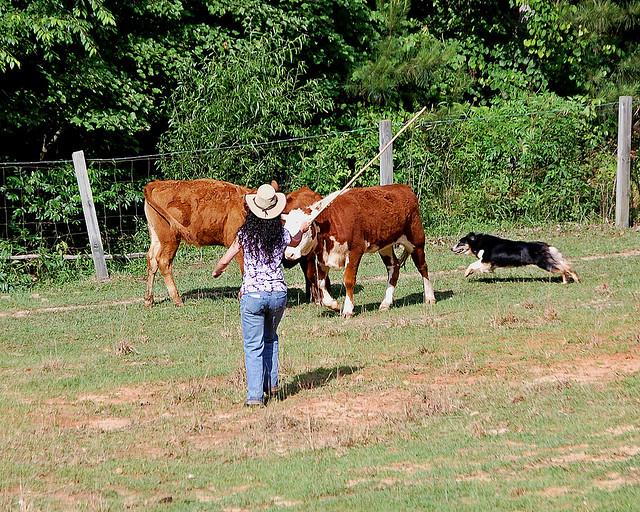Is all of the grass green?
Concise answer only. No. Why is this lady wearing a hat?
Keep it brief. Shade. What is the dog doing?
Concise answer only. Running. 